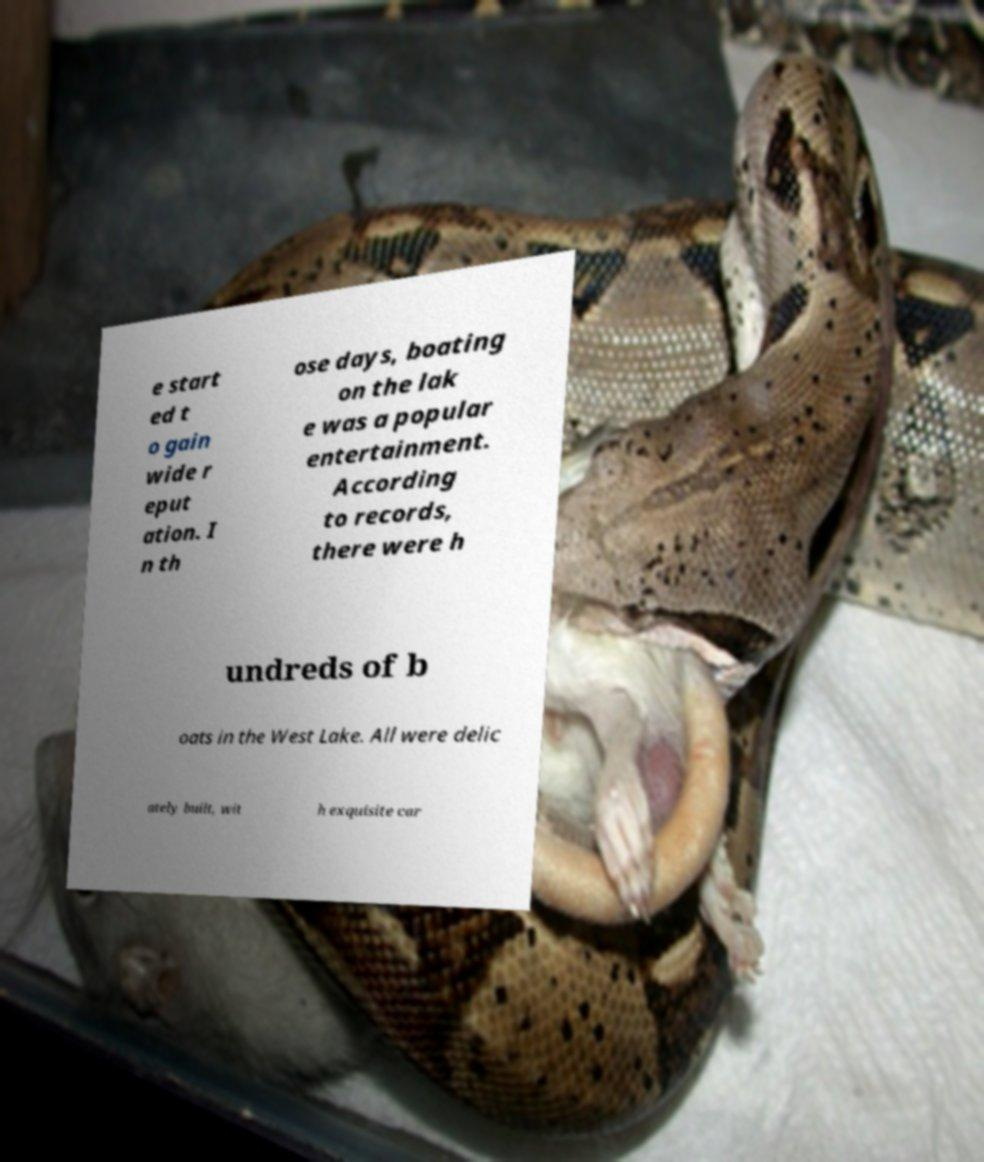Please read and relay the text visible in this image. What does it say? e start ed t o gain wide r eput ation. I n th ose days, boating on the lak e was a popular entertainment. According to records, there were h undreds of b oats in the West Lake. All were delic ately built, wit h exquisite car 